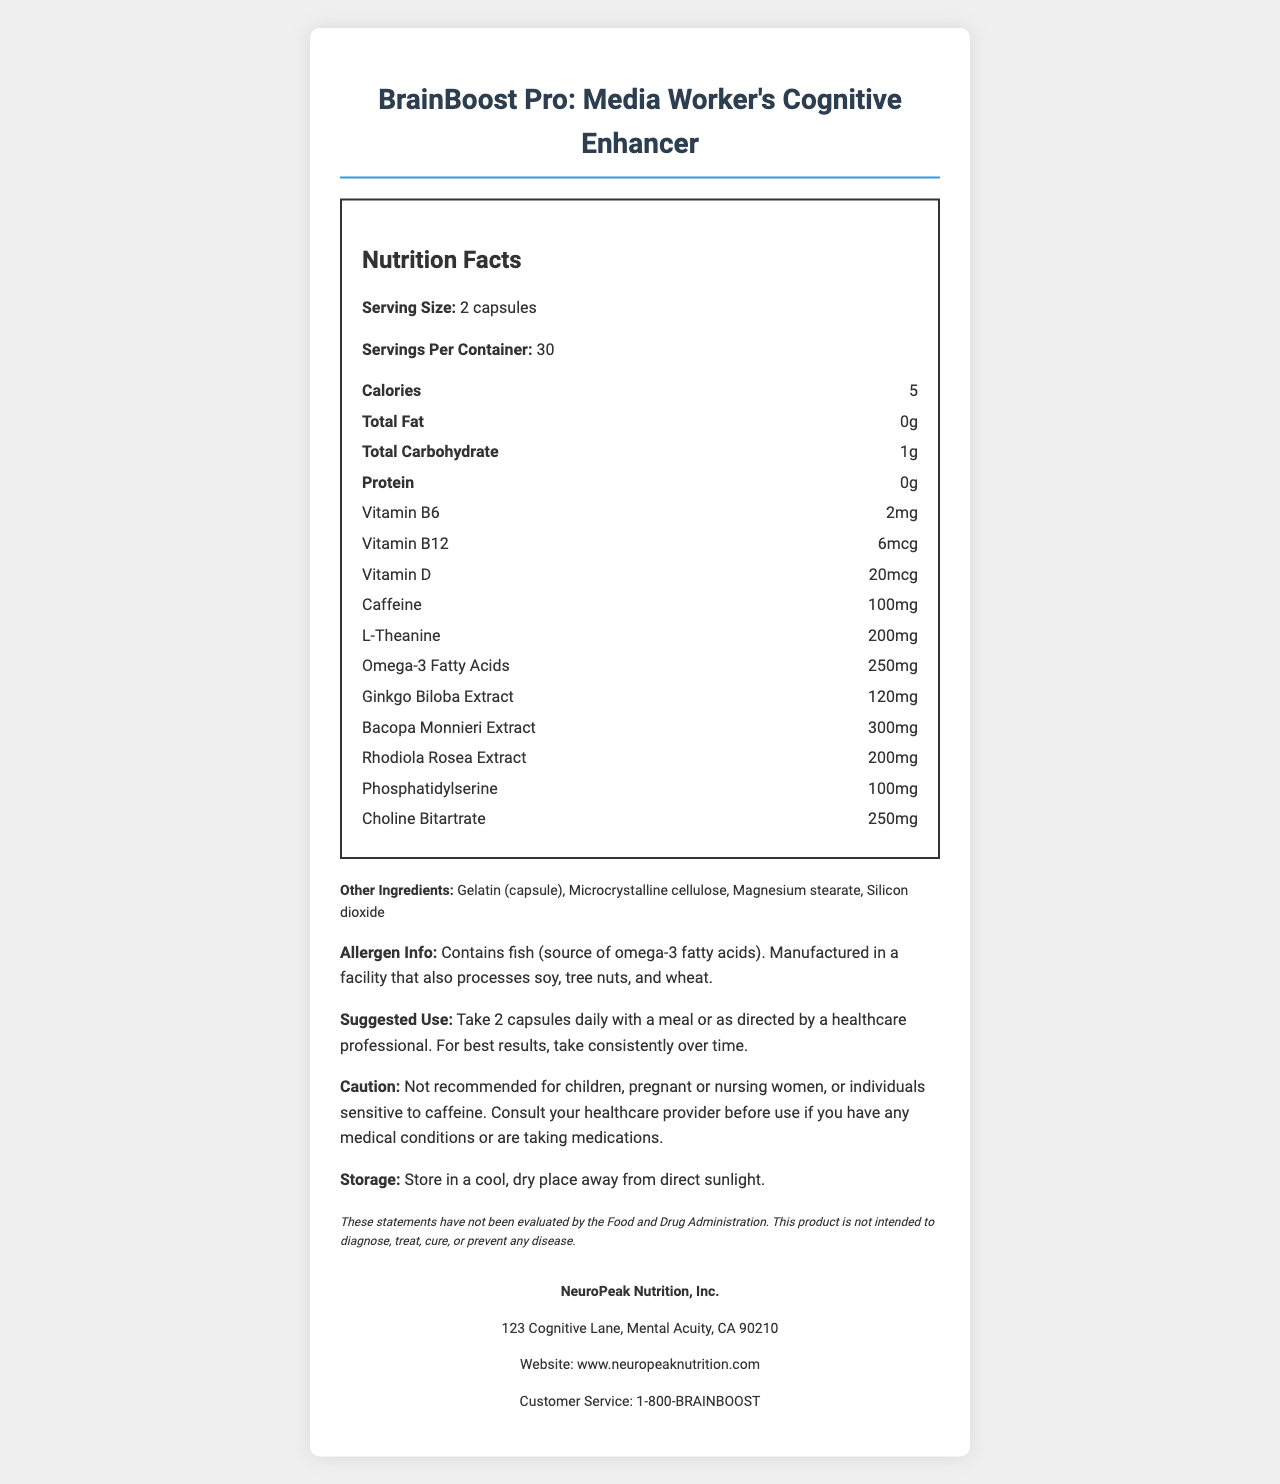what is the serving size of BrainBoost Pro? The serving size is specifically mentioned as "2 capsules" in the document.
Answer: 2 capsules how many servings are there per container? The document states that there are 30 servings per container.
Answer: 30 how many calories are there per serving? The calorie content per serving is listed as 5 in the document.
Answer: 5 calories which vitamin has the highest amount per serving? The amounts of different vitamins are listed, and Vitamin D has the highest amount at 20mcg.
Answer: Vitamin D what is the primary caution regarding the use of this product? The caution section specifies these recommendations clearly.
Answer: Not recommended for children, pregnant or nursing women, or individuals sensitive to caffeine. Consult your healthcare provider before use if you have any medical conditions or are taking medications. what is the main source of omega-3 fatty acids in this supplement? A. Flaxseed B. Fish C. Chia Seeds D. Algae The allergen info section mentions that the product contains fish, which is the source of omega-3 fatty acids.
Answer: B. Fish which ingredient is not listed in the 'other ingredients' section? I. Gelatin II. Microcrystalline cellulose III. Magnesium stearate IV. Ascorbic acid Ascorbic acid is not listed; the other ingredients are Gelatin, Microcrystalline cellulose, and Magnesium stearate which are mentioned.
Answer: IV. Ascorbic acid can this product diagnose, treat, cure, or prevent any disease? The disclaimer clearly states that the product is not intended to diagnose, treat, cure, or prevent any disease.
Answer: No is this product recommended for children? The caution section specifically says it is not recommended for children.
Answer: No how should the BrainBoost Pro supplements be stored? Storage instructions are given as storing in a cool, dry place away from direct sunlight.
Answer: In a cool, dry place away from direct sunlight. what is a unique feature of BrainBoost Pro targeted to media workers? The product name itself indicates that it is a cognitive enhancer aimed at media workers.
Answer: Boosts cognitive function and alertness how much caffeine does each serving contain? The document lists 100mg of caffeine per serving.
Answer: 100mg what are the key ingredients that support cognitive function in BrainBoost Pro? These ingredients are listed as part of the nutrient breakdown in the document and are associated with cognitive enhancement.
Answer: Caffeine, L-Theanine, Ginkgo Biloba Extract, Bacopa Monnieri Extract, Rhodiola Rosea Extract, Phosphatidylserine, Choline Bitartrate does BrainBoost Pro contain any common allergens? The document mentions that it contains fish and is manufactured in a facility that also processes soy, tree nuts, and wheat.
Answer: Yes can you use BrainBoost Pro if you are pregnant? The caution section advises against using the product if pregnant or nursing.
Answer: No summarize the main idea of the document. This summary covers the key sections and purpose of the document.
Answer: The document is a Nutrition Facts Label for BrainBoost Pro, a vitamin supplement marketed to boost cognitive function and alertness in media workers. It details serving size, nutrient information, ingredients, allergen info, suggested use, cautions, storage instructions, a disclaimer, and manufacturer's contact information. how did the manufacturer ensure quality control procedures? The document does not provide details on the quality control procedures employed by the manufacturer.
Answer: Not enough information 